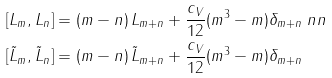Convert formula to latex. <formula><loc_0><loc_0><loc_500><loc_500>[ L _ { m } , L _ { n } ] & = ( m - n ) \, L _ { m + n } + \frac { c _ { V } } { 1 2 } ( m ^ { 3 } - m ) \delta _ { m + n } \ n n \\ [ \tilde { L } _ { m } , \tilde { L } _ { n } ] & = ( m - n ) \, \tilde { L } _ { m + n } + \frac { c _ { V } } { 1 2 } ( m ^ { 3 } - m ) \delta _ { m + n }</formula> 